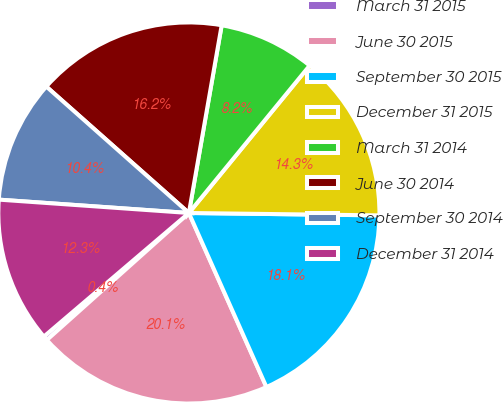<chart> <loc_0><loc_0><loc_500><loc_500><pie_chart><fcel>March 31 2015<fcel>June 30 2015<fcel>September 30 2015<fcel>December 31 2015<fcel>March 31 2014<fcel>June 30 2014<fcel>September 30 2014<fcel>December 31 2014<nl><fcel>0.38%<fcel>20.06%<fcel>18.13%<fcel>14.28%<fcel>8.17%<fcel>16.21%<fcel>10.43%<fcel>12.35%<nl></chart> 